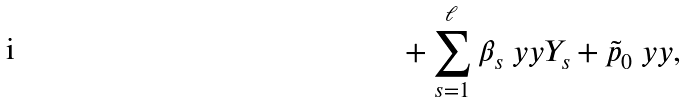Convert formula to latex. <formula><loc_0><loc_0><loc_500><loc_500>+ \sum _ { s = 1 } ^ { \ell } \beta _ { s } \ y y Y _ { s } + \tilde { p } _ { 0 } \ y y ,</formula> 